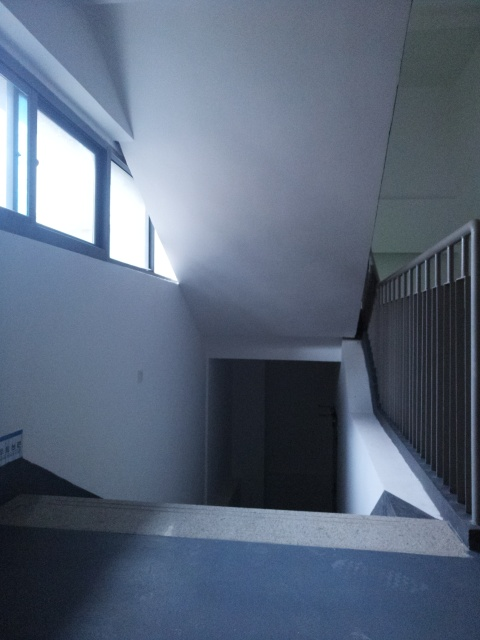Could you describe the mood this image conveys? The image conveys a mood of quietness and solitude, with the cool color tones and the empty space suggesting a sense of stillness, potentially evoking feelings of introspection or loneliness. 